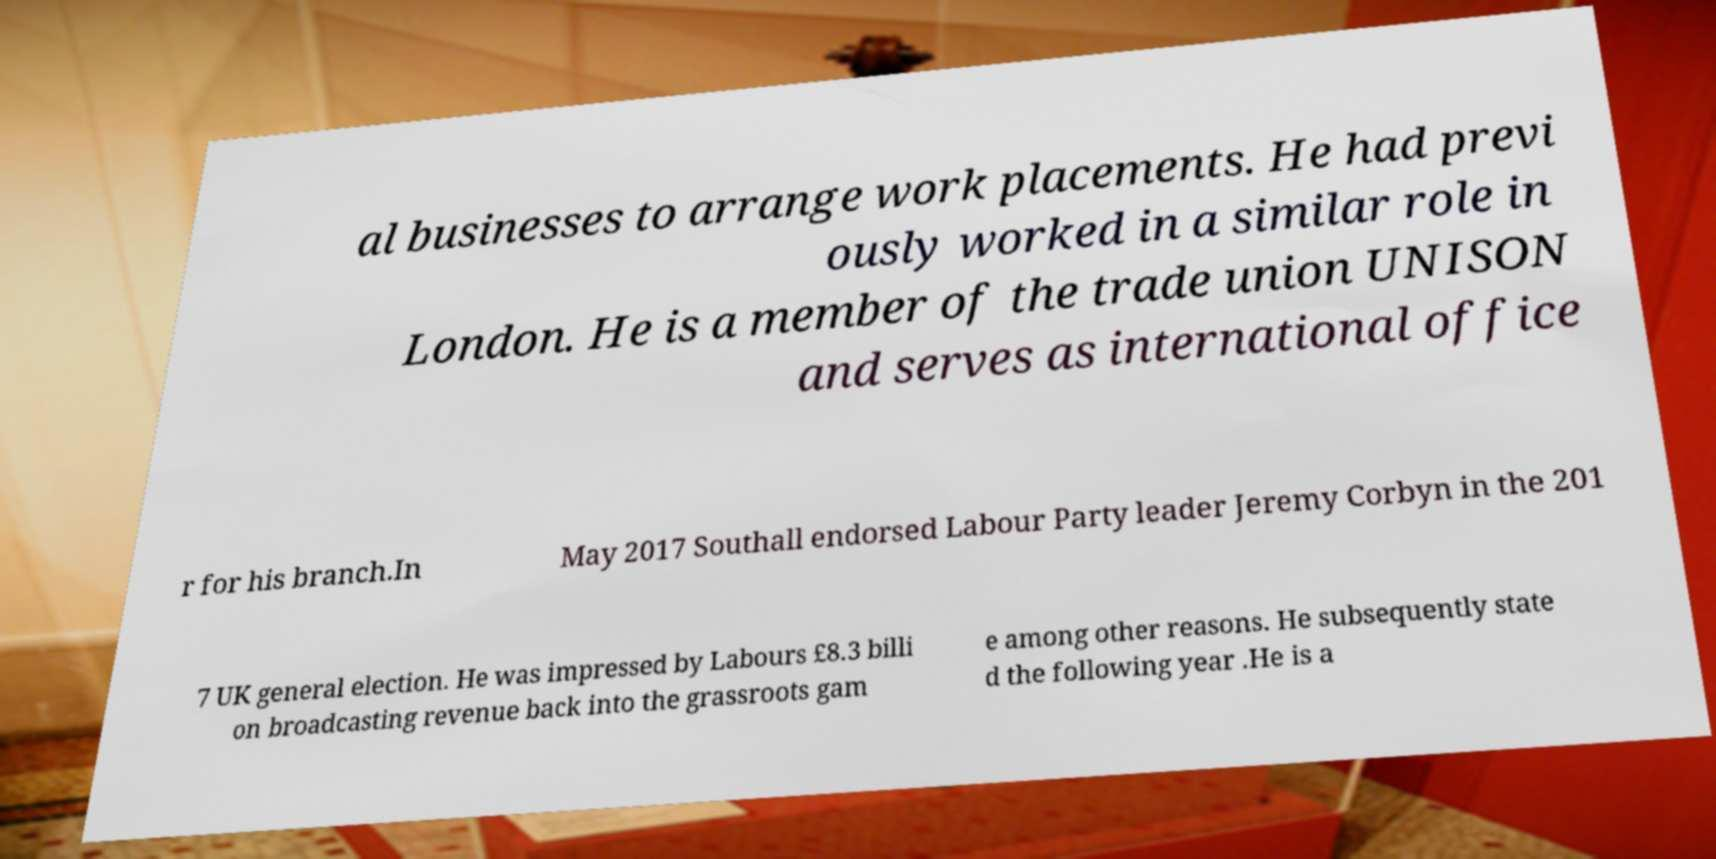Could you extract and type out the text from this image? al businesses to arrange work placements. He had previ ously worked in a similar role in London. He is a member of the trade union UNISON and serves as international office r for his branch.In May 2017 Southall endorsed Labour Party leader Jeremy Corbyn in the 201 7 UK general election. He was impressed by Labours £8.3 billi on broadcasting revenue back into the grassroots gam e among other reasons. He subsequently state d the following year .He is a 